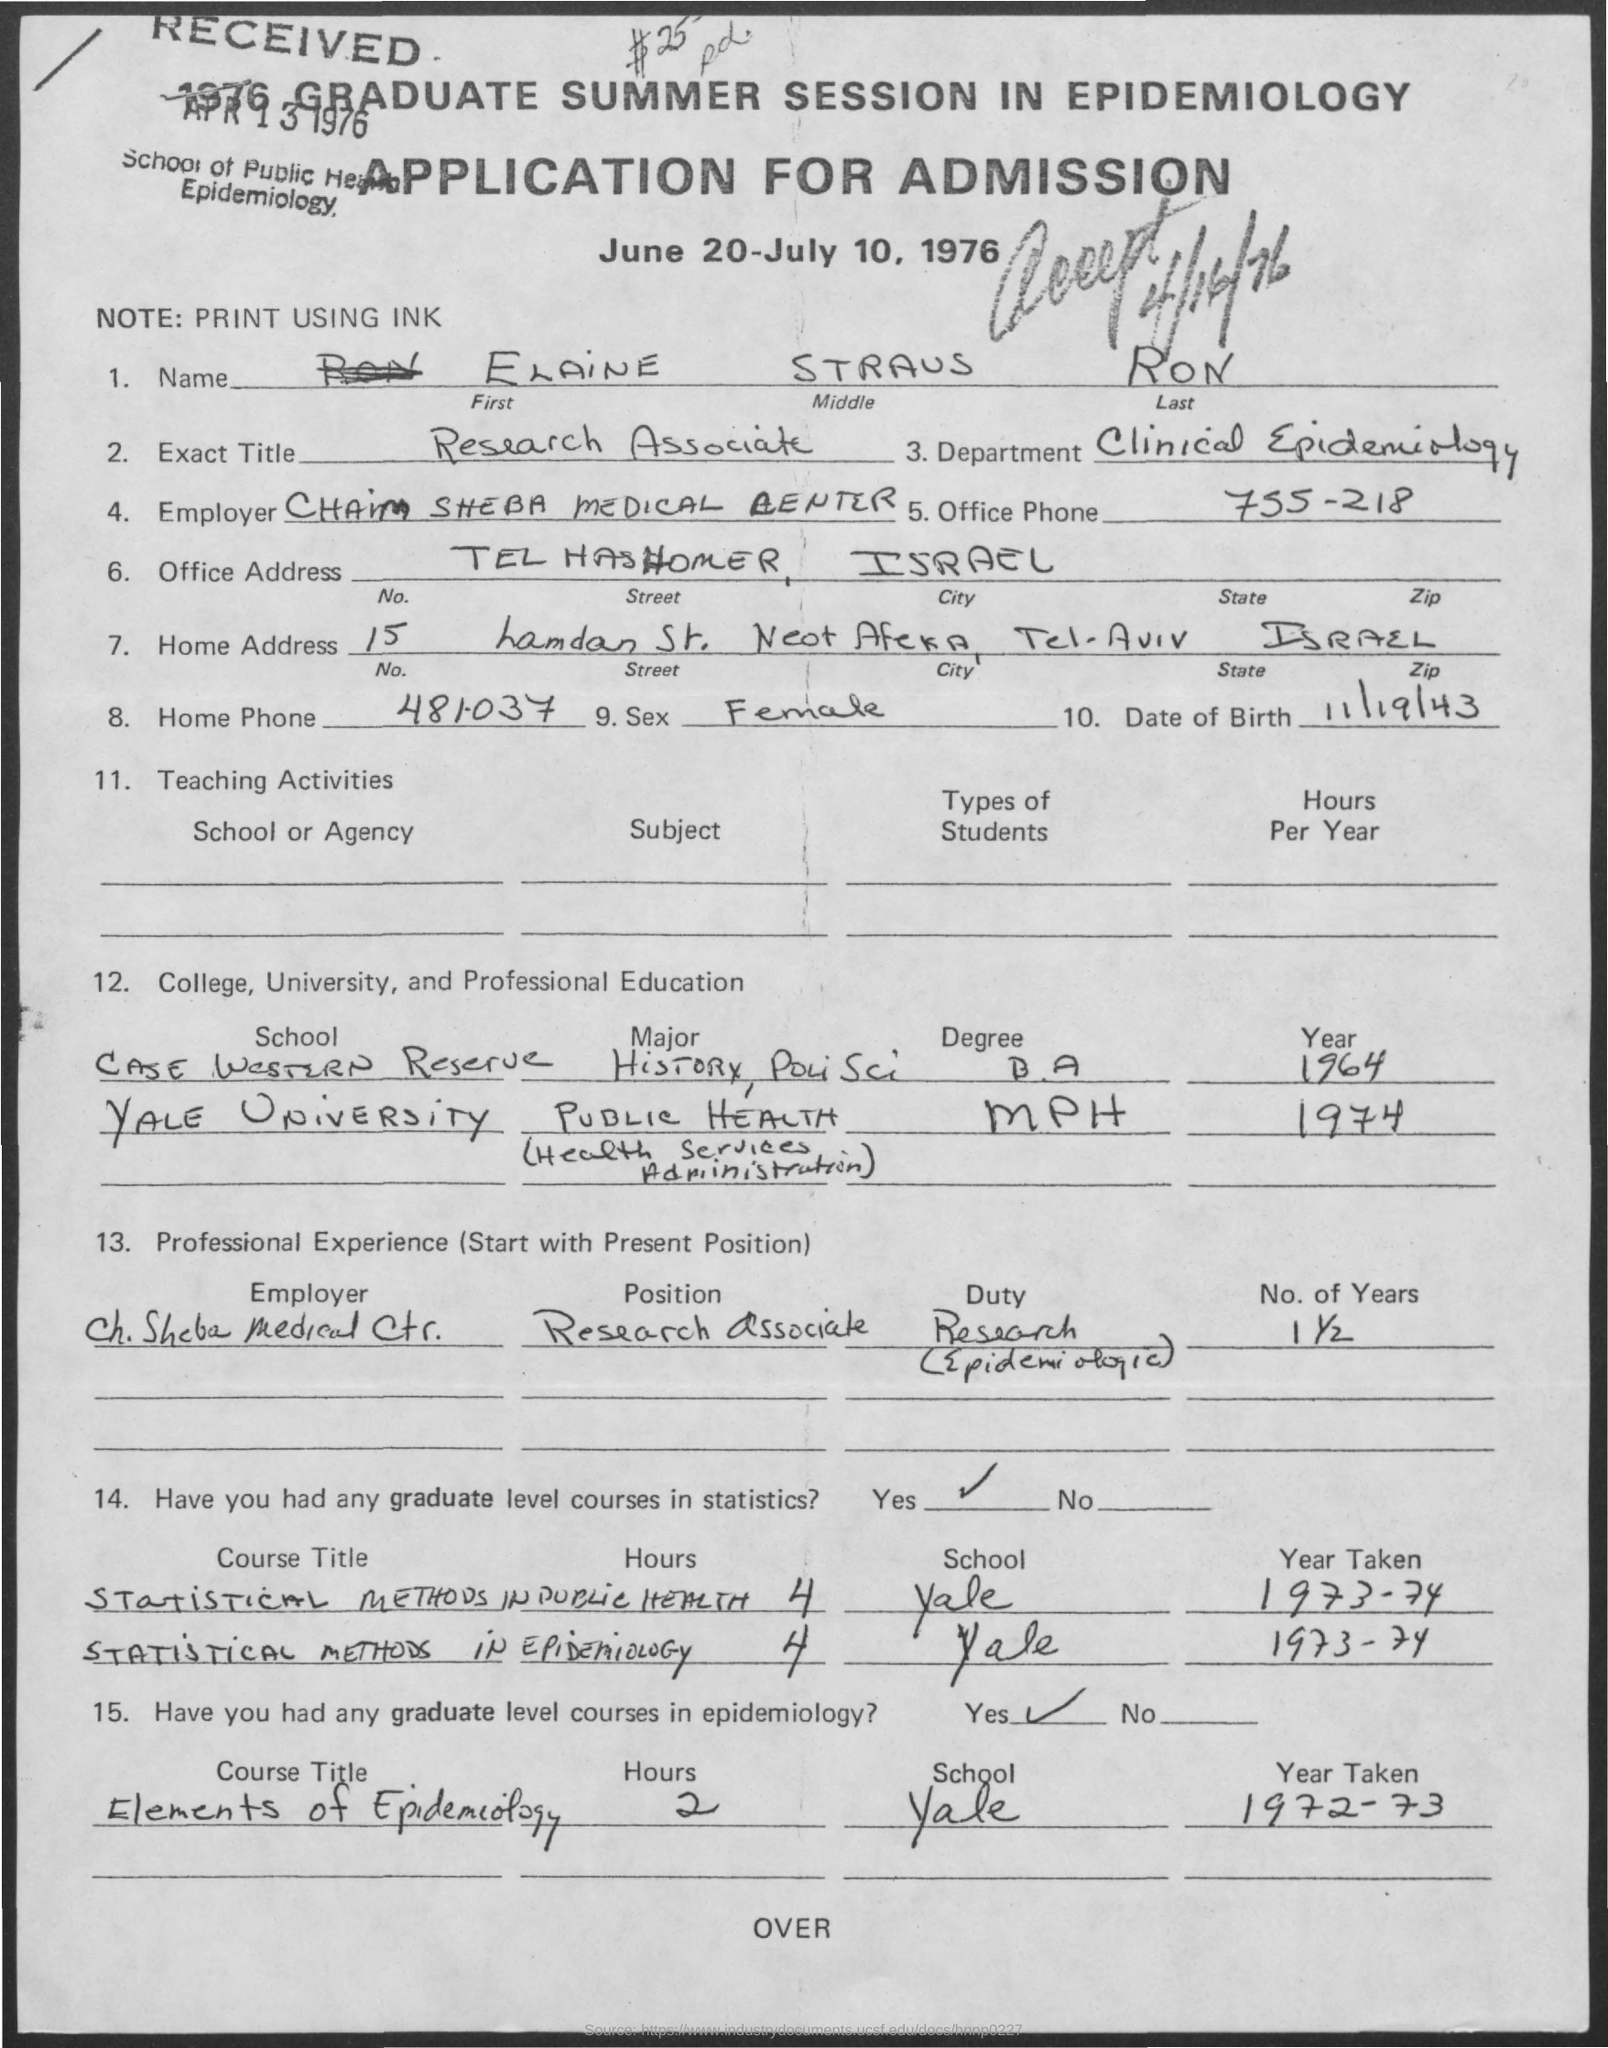What is the name given?
Your answer should be compact. ELAiNE STRAUS RON. Which department was Elaine part of?
Give a very brief answer. Clinical Epidemiology. Which course was taken in the year 1972-73 from Yale?
Keep it short and to the point. ELEMENTS OF EPIDEMIOLOGY. 